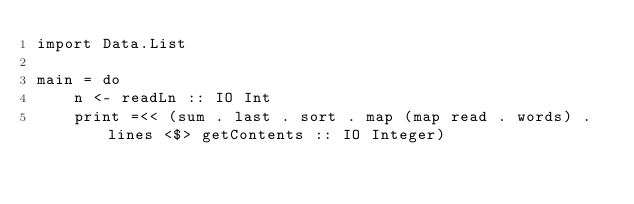<code> <loc_0><loc_0><loc_500><loc_500><_Haskell_>import Data.List

main = do
	n <- readLn :: IO Int
	print =<< (sum . last . sort . map (map read . words) . lines <$> getContents :: IO Integer)</code> 